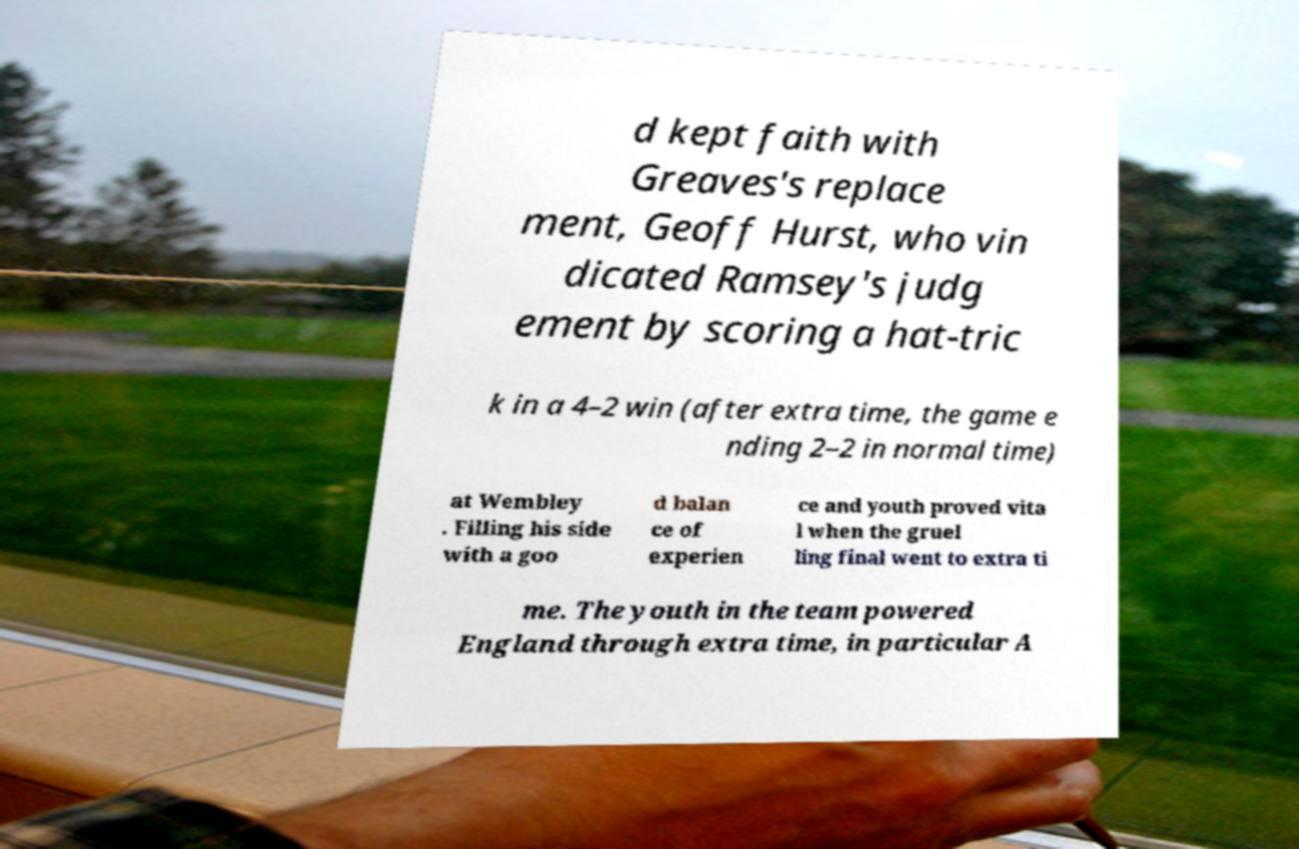Can you read and provide the text displayed in the image?This photo seems to have some interesting text. Can you extract and type it out for me? d kept faith with Greaves's replace ment, Geoff Hurst, who vin dicated Ramsey's judg ement by scoring a hat-tric k in a 4–2 win (after extra time, the game e nding 2–2 in normal time) at Wembley . Filling his side with a goo d balan ce of experien ce and youth proved vita l when the gruel ling final went to extra ti me. The youth in the team powered England through extra time, in particular A 